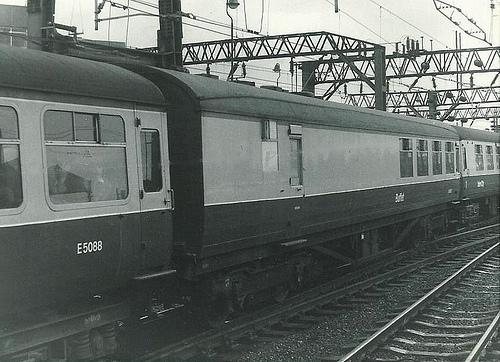Question: what are the metal things on the ground?
Choices:
A. Patio chairs.
B. Pans.
C. Pipes.
D. Railroad tracks.
Answer with the letter. Answer: D Question: what shape are the train's windows?
Choices:
A. Rectangles.
B. Circles.
C. Rounded squares.
D. Triangle.
Answer with the letter. Answer: C Question: what type of train is it?
Choices:
A. Coal.
B. Steam.
C. Electric.
D. Gasoline.
Answer with the letter. Answer: C 